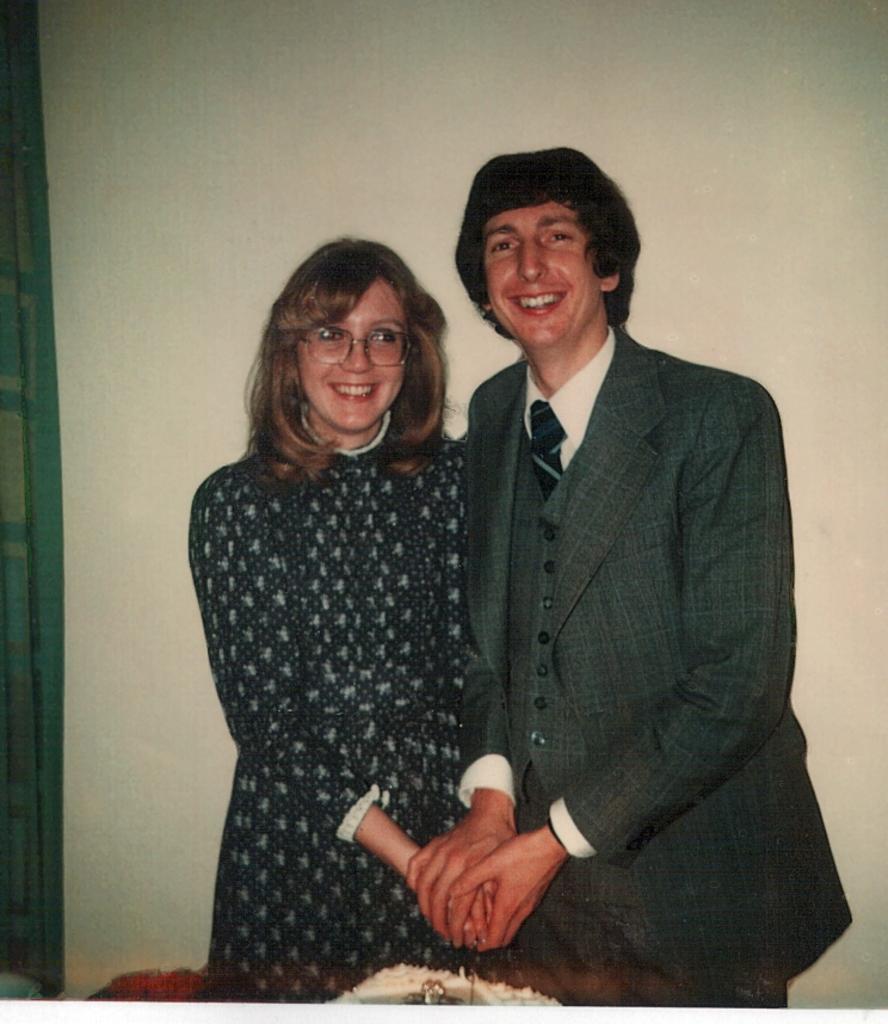Please provide a concise description of this image. This image is taken indoors. In the background there is a wall. In the middle of the image a man and a woman are standing on the floor and they are with smiling faces. At the bottom of the image there is a table with a cake on it. 